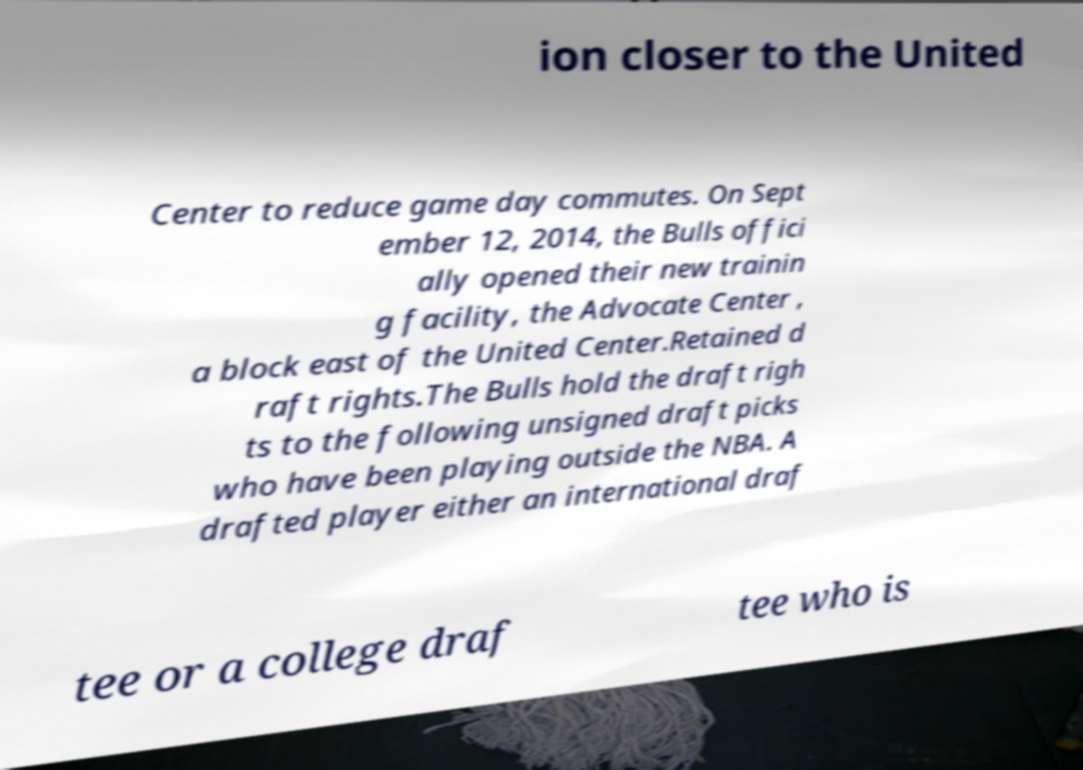What messages or text are displayed in this image? I need them in a readable, typed format. ion closer to the United Center to reduce game day commutes. On Sept ember 12, 2014, the Bulls offici ally opened their new trainin g facility, the Advocate Center , a block east of the United Center.Retained d raft rights.The Bulls hold the draft righ ts to the following unsigned draft picks who have been playing outside the NBA. A drafted player either an international draf tee or a college draf tee who is 